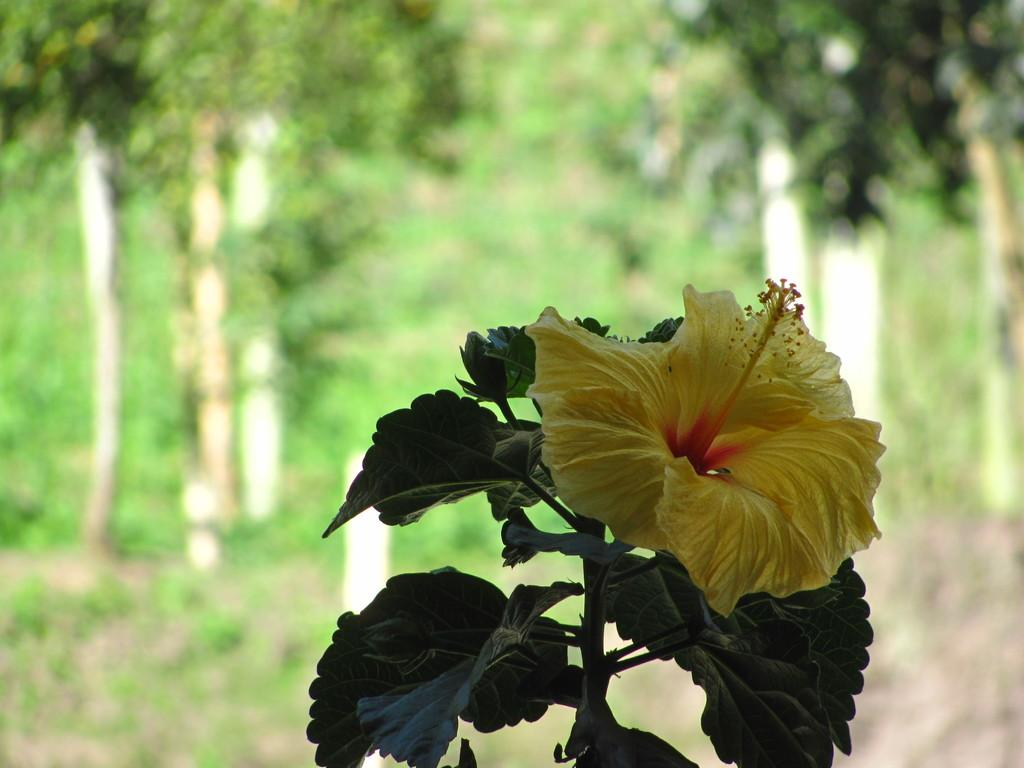What type of flower is in the image? There is a hibiscus flower in the image. Where is the flower located? The flower is on a plant. What can be observed about the background of the plant? The background of the plant is blurred. Can you tell me how many receipts are visible in the image? There are no receipts present in the image; it features a hibiscus flower on a plant with a blurred background. 